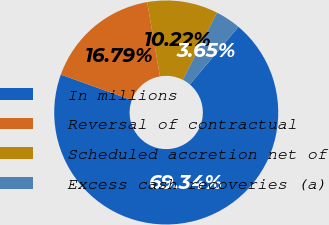Convert chart to OTSL. <chart><loc_0><loc_0><loc_500><loc_500><pie_chart><fcel>In millions<fcel>Reversal of contractual<fcel>Scheduled accretion net of<fcel>Excess cash recoveries (a)<nl><fcel>69.35%<fcel>16.79%<fcel>10.22%<fcel>3.65%<nl></chart> 